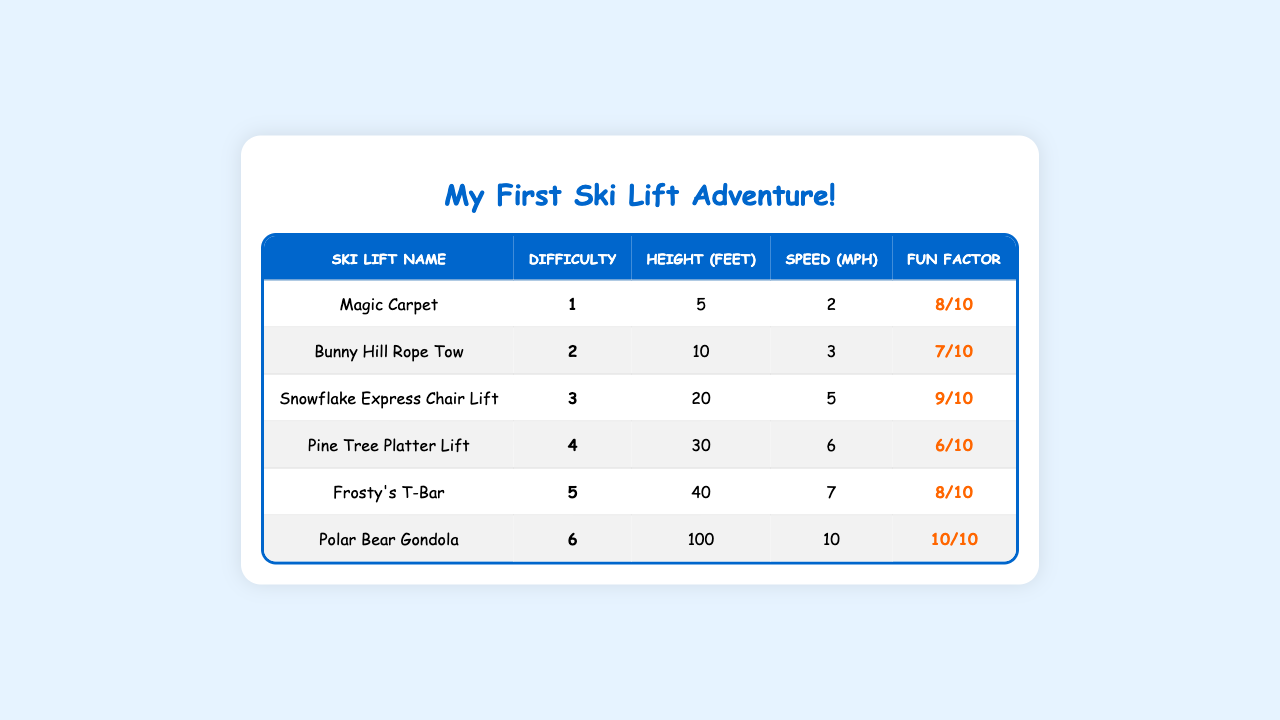What's the name of the ski lift with the highest speed? The table shows the speeds of all ski lifts, and the Polar Bear Gondola has the highest speed at 10 mph.
Answer: Polar Bear Gondola Which ski lift has a fun factor of 6? By scanning the fun factor column, we can see that the Pine Tree Platter Lift has a fun factor of 6.
Answer: Pine Tree Platter Lift Is the Frosty's T-Bar more difficult than the Snowflake Express Chair Lift? The Frosty's T-Bar has a difficulty level of 5, while the Snowflake Express Chair Lift has a difficulty level of 3. Since 5 is greater than 3, Frosty's T-Bar is indeed more difficult.
Answer: Yes What is the average height of the ski lifts? The heights of the ski lifts are 5, 10, 20, 30, 40, and 100 feet. Adding them together gives 205 feet. Since there are 6 lifts, the average height is 205/6 = 34.17 feet.
Answer: 34.17 feet Which ski lift is the easiest and how high is it? The easiest ski lift is the Magic Carpet with a difficulty level of 1. Its height is 5 feet, as shown in the table.
Answer: Magic Carpet, 5 feet How does the fun factor of the Polar Bear Gondola compare to the Magic Carpet? The Polar Bear Gondola has a fun factor of 10, while the Magic Carpet has a fun factor of 8. Since 10 is greater than 8, the Polar Bear Gondola is more fun.
Answer: Yes, it's more fun What is the total speed of all ski lifts combined? The speeds of the ski lifts are 2, 3, 5, 6, 7, and 10 mph. Adding these gives 2 + 3 + 5 + 6 + 7 + 10 = 33 mph.
Answer: 33 mph Which ski lift has a fun factor of 9 and what is its difficulty level? Scanning the table, the Snowflake Express Chair Lift has a fun factor of 9, and its difficulty level is 3.
Answer: Snowflake Express Chair Lift, difficulty level 3 Which ski lift is less than 10 feet high and has a difficulty of 2 or more? The only ski lift that fits this description is the Bunny Hill Rope Tow, which is 10 feet high and has a difficulty of 2. Since it is exactly 10 feet, it cannot be less than 10 feet, so there isn't one.
Answer: No ski lift If I want to ski on a lift with a fun factor of 8 or more, which lifts should I choose? The ski lifts with a fun factor of 8 or more are the Magic Carpet (8), Frosty's T-Bar (8), and Polar Bear Gondola (10).
Answer: Magic Carpet, Frosty's T-Bar, Polar Bear Gondola 